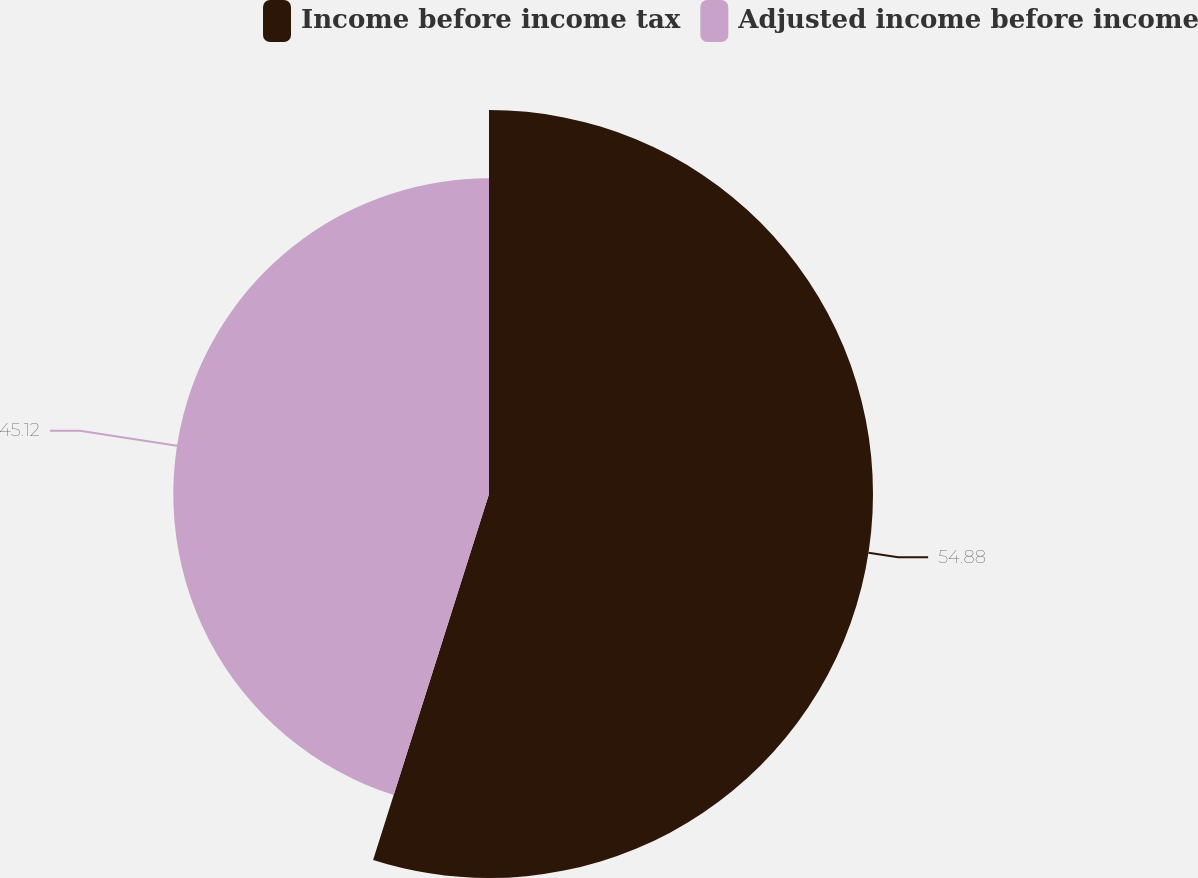<chart> <loc_0><loc_0><loc_500><loc_500><pie_chart><fcel>Income before income tax<fcel>Adjusted income before income<nl><fcel>54.88%<fcel>45.12%<nl></chart> 